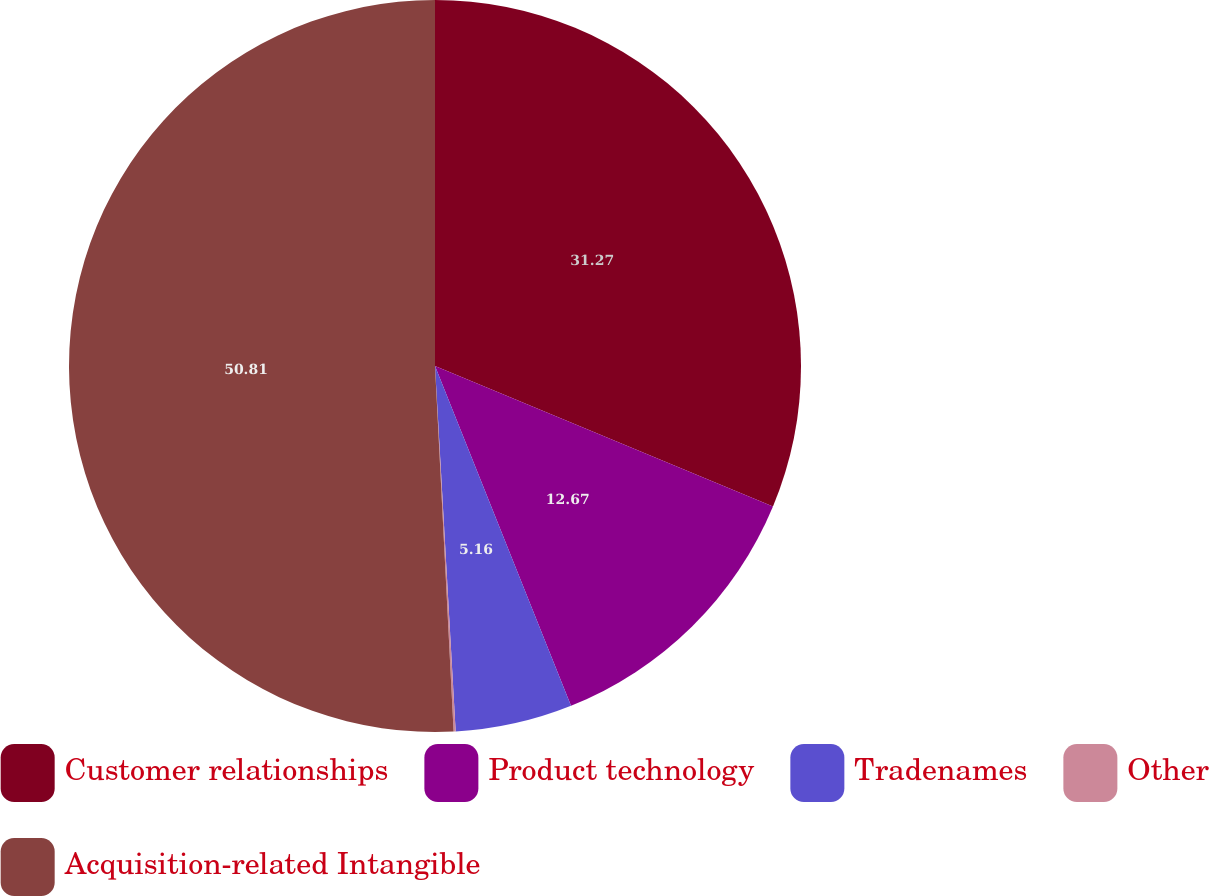Convert chart to OTSL. <chart><loc_0><loc_0><loc_500><loc_500><pie_chart><fcel>Customer relationships<fcel>Product technology<fcel>Tradenames<fcel>Other<fcel>Acquisition-related Intangible<nl><fcel>31.27%<fcel>12.67%<fcel>5.16%<fcel>0.09%<fcel>50.81%<nl></chart> 